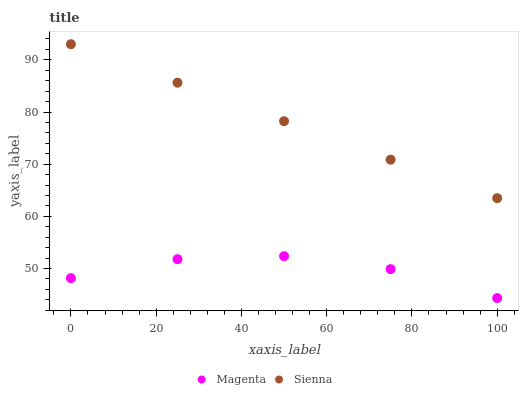Does Magenta have the minimum area under the curve?
Answer yes or no. Yes. Does Sienna have the maximum area under the curve?
Answer yes or no. Yes. Does Magenta have the maximum area under the curve?
Answer yes or no. No. Is Sienna the smoothest?
Answer yes or no. Yes. Is Magenta the roughest?
Answer yes or no. Yes. Is Magenta the smoothest?
Answer yes or no. No. Does Magenta have the lowest value?
Answer yes or no. Yes. Does Sienna have the highest value?
Answer yes or no. Yes. Does Magenta have the highest value?
Answer yes or no. No. Is Magenta less than Sienna?
Answer yes or no. Yes. Is Sienna greater than Magenta?
Answer yes or no. Yes. Does Magenta intersect Sienna?
Answer yes or no. No. 